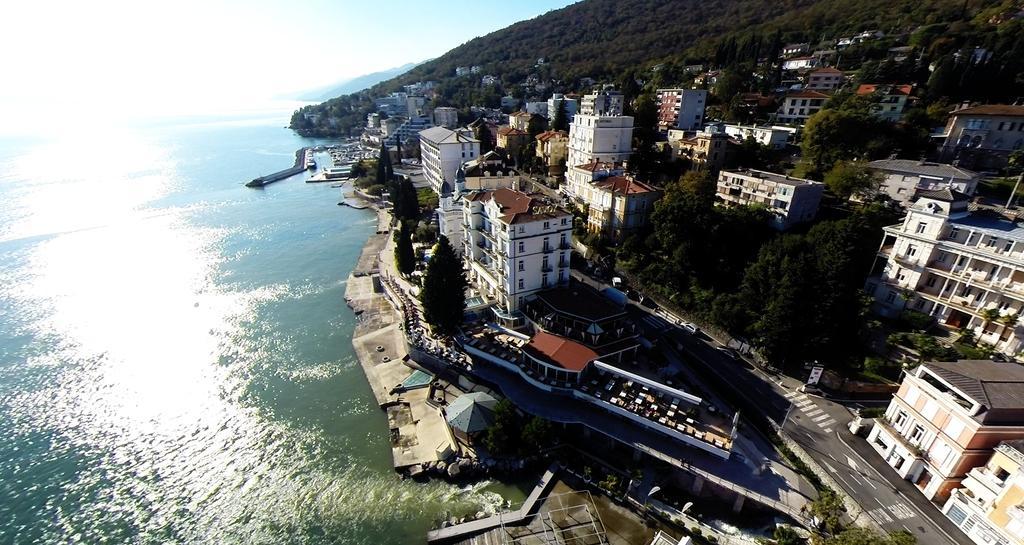Could you give a brief overview of what you see in this image? This is an aerial view of an image where we can see the water, buildings, the road, trees, hills and the sky in the background. 